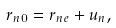<formula> <loc_0><loc_0><loc_500><loc_500>r _ { n 0 } = r _ { n e } + u _ { n } ,</formula> 